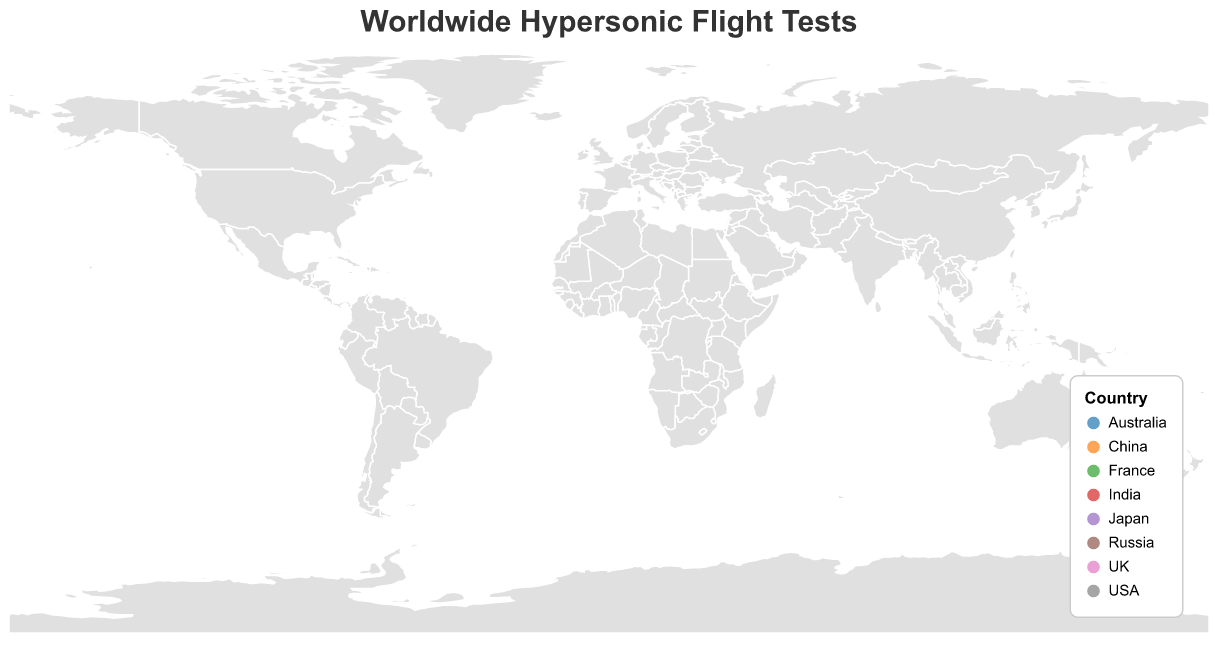What's the title of the figure? The title is generally located at the top center of the figure. Looking at the figure, the title is "Worldwide Hypersonic Flight Tests"
Answer: Worldwide Hypersonic Flight Tests How many countries have conducted successful hypersonic flight tests? The data points represent different countries, each marked with a circle. Counting the unique countries listed in the tooltip or legend, we find there are 8 countries: USA, Russia, China, India, Australia, Japan, France, and the UK
Answer: 8 Which hypersonic flight test has the highest maximum speed? By examining the tooltip information, the flight test with the highest maximum speed can be identified. The "Avangard" test conducted by Russia in 2018 has a maximum speed of Mach 27.0
Answer: Avangard What is the average maximum speed achieved by all the flight tests? First, sum all the maximum speeds: 5.1 (USA) + 27.0 (Russia) + 10.0 (China) + 6.0 (India) + 7.5 (Australia) + 5.8 (Japan) + 8.0 (France) + 6.5 (UK). This equals 75.9. Divide by the number of tests, which is 8. So, 75.9 / 8 = 9.49
Answer: 9.49 Mach Which country conducted the most recent hypersonic flight test? The year for each flight test is displayed in the tooltip. The most recent year is 2022, and the country is Japan with the "HSFT-2" test.
Answer: Japan Compare the maximum speeds of the USA and the UK flights, which one is higher? According to the tooltip details, the maximum speed of the USA's X-51A WaveRider is Mach 5.1, and the UK's Tempest HVW is Mach 6.5. The UK's maximum speed is higher
Answer: UK Which continents host countries that have conducted hypersonic flight tests? Observing the world map, the countries span several continents: North America (USA), Europe (Russia, France, UK), Asia (China, India, Japan), and Australia (Australia)
Answer: North America, Europe, Asia, Australia What is the difference in maximum speed between the flight tests of Russia and Japan? According to the tooltips, Russia's Avangard has a maximum speed of Mach 27.0, and Japan's HSFT-2 has Mach 5.8. The difference is 27.0 - 5.8 = 21.2
Answer: 21.2 Mach What is the most common maximum speed range among the hypersonic flight tests? By observing the tooltip data on the figure, most of the hypersonic flights (more than half) have maximum speeds between Mach 5 and Mach 10 (USA, China, India, Japan, and Australia)
Answer: Mach 5 to Mach 10 